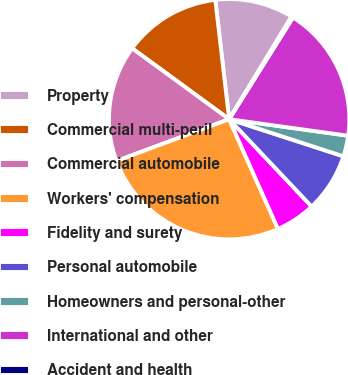Convert chart to OTSL. <chart><loc_0><loc_0><loc_500><loc_500><pie_chart><fcel>Property<fcel>Commercial multi-peril<fcel>Commercial automobile<fcel>Workers' compensation<fcel>Fidelity and surety<fcel>Personal automobile<fcel>Homeowners and personal-other<fcel>International and other<fcel>Accident and health<nl><fcel>10.54%<fcel>13.12%<fcel>15.7%<fcel>26.02%<fcel>5.38%<fcel>7.96%<fcel>2.8%<fcel>18.28%<fcel>0.22%<nl></chart> 